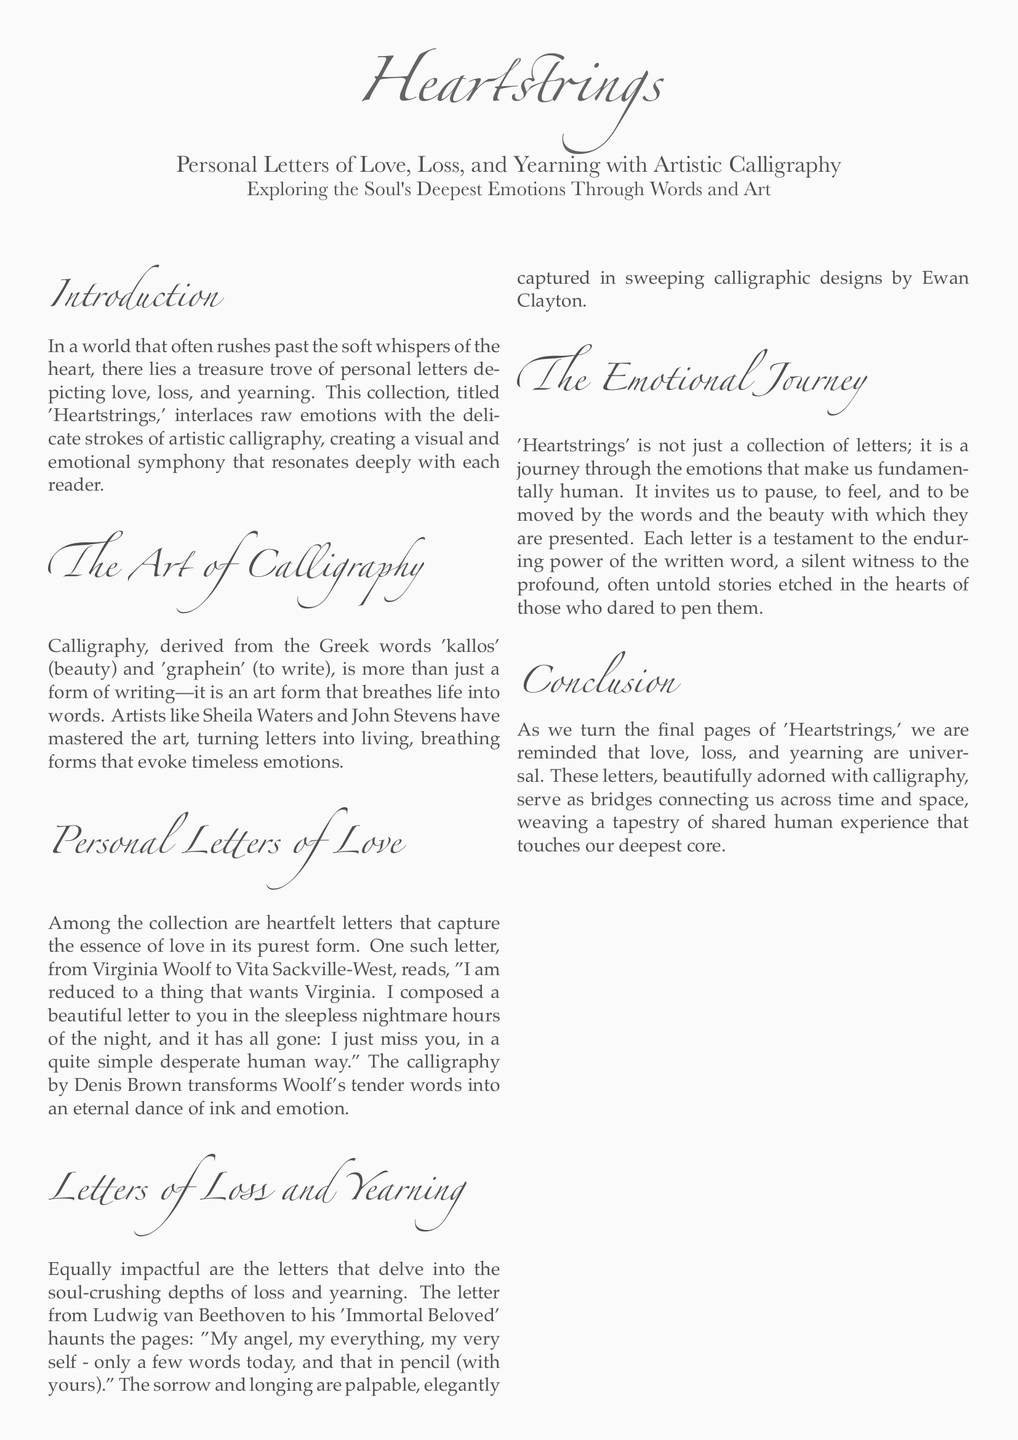What is the title of the collection? The title of the collection is explicitly mentioned in the introduction section of the document.
Answer: Heartstrings Who is the editor of the magazine? The editor's name is listed under the credits section of the document.
Answer: Amelia Hart Which two calligraphy artists are mentioned in the document? The document lists multiple calligraphy artists under the credits section; choosing any two will provide an answer.
Answer: Sheila Waters, John Stevens What type of letters does 'Heartstrings' explore? The document describes the type of letters explored within the collection.
Answer: Love, Loss, and Yearning Who wrote a letter to Vita Sackville-West? The document provides the author of a notable letter included in the collection.
Answer: Virginia Woolf What emotion is conveyed in Beethoven's letter? The content of Beethoven's letter conveys a specific feeling described in the section.
Answer: Longing What is the page color used throughout the document? The document specifies the background color that sets the tone for the visual layout.
Answer: bggray What is the main purpose of 'Heartstrings'? The document elaborates on the function or intention of the collection elaborated in the emotional journey section.
Answer: A journey through the emotions What artistic approach is highlighted in the collection? The document refers to a specific art form associated with the letters in the collection.
Answer: Calligraphy 